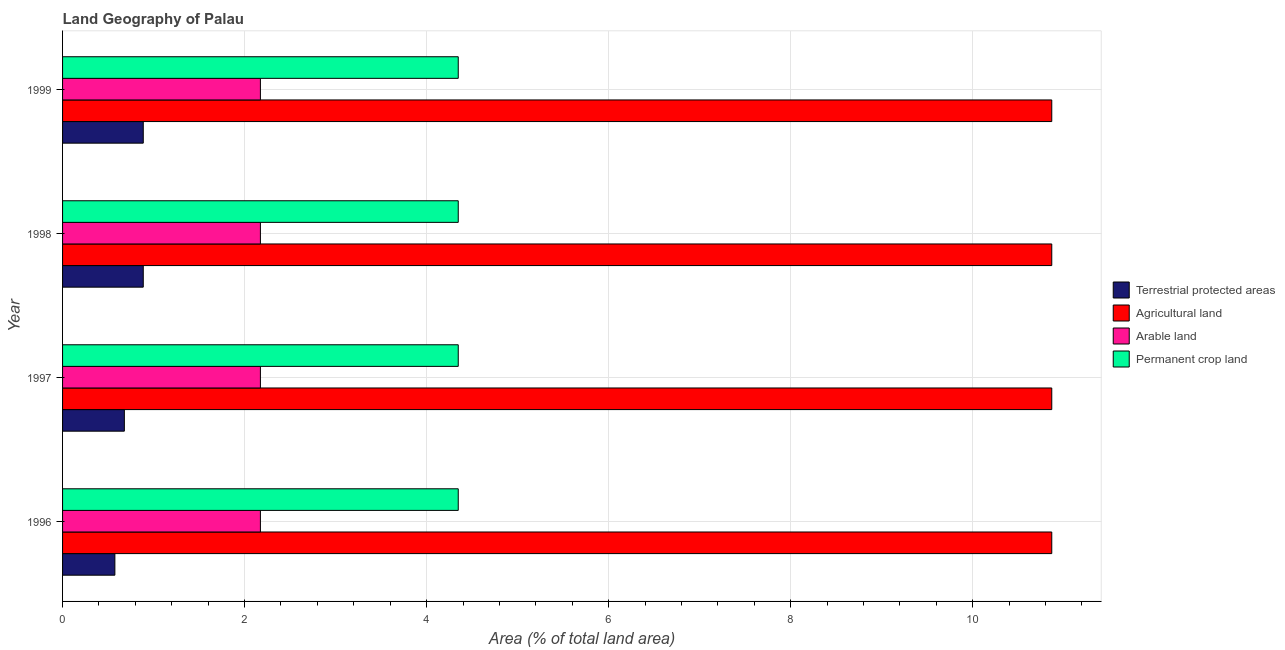What is the label of the 2nd group of bars from the top?
Provide a short and direct response. 1998. What is the percentage of area under permanent crop land in 1996?
Keep it short and to the point. 4.35. Across all years, what is the maximum percentage of area under arable land?
Provide a succinct answer. 2.17. Across all years, what is the minimum percentage of area under agricultural land?
Provide a succinct answer. 10.87. What is the total percentage of land under terrestrial protection in the graph?
Provide a short and direct response. 3.03. What is the difference between the percentage of land under terrestrial protection in 1996 and the percentage of area under permanent crop land in 1998?
Offer a very short reply. -3.77. What is the average percentage of land under terrestrial protection per year?
Make the answer very short. 0.76. In the year 1999, what is the difference between the percentage of area under arable land and percentage of area under agricultural land?
Your answer should be compact. -8.7. What is the ratio of the percentage of area under arable land in 1996 to that in 1997?
Provide a succinct answer. 1. What is the difference between the highest and the second highest percentage of area under arable land?
Offer a very short reply. 0. In how many years, is the percentage of land under terrestrial protection greater than the average percentage of land under terrestrial protection taken over all years?
Offer a terse response. 2. Is the sum of the percentage of area under permanent crop land in 1996 and 1999 greater than the maximum percentage of area under arable land across all years?
Provide a succinct answer. Yes. Is it the case that in every year, the sum of the percentage of area under arable land and percentage of land under terrestrial protection is greater than the sum of percentage of area under agricultural land and percentage of area under permanent crop land?
Your response must be concise. Yes. What does the 3rd bar from the top in 1997 represents?
Your response must be concise. Agricultural land. What does the 2nd bar from the bottom in 1998 represents?
Ensure brevity in your answer.  Agricultural land. Is it the case that in every year, the sum of the percentage of land under terrestrial protection and percentage of area under agricultural land is greater than the percentage of area under arable land?
Your answer should be compact. Yes. Are the values on the major ticks of X-axis written in scientific E-notation?
Provide a short and direct response. No. Does the graph contain any zero values?
Keep it short and to the point. No. How many legend labels are there?
Provide a succinct answer. 4. What is the title of the graph?
Your answer should be compact. Land Geography of Palau. Does "Oil" appear as one of the legend labels in the graph?
Give a very brief answer. No. What is the label or title of the X-axis?
Your response must be concise. Area (% of total land area). What is the Area (% of total land area) of Terrestrial protected areas in 1996?
Ensure brevity in your answer.  0.57. What is the Area (% of total land area) of Agricultural land in 1996?
Keep it short and to the point. 10.87. What is the Area (% of total land area) in Arable land in 1996?
Offer a very short reply. 2.17. What is the Area (% of total land area) in Permanent crop land in 1996?
Make the answer very short. 4.35. What is the Area (% of total land area) of Terrestrial protected areas in 1997?
Your answer should be compact. 0.68. What is the Area (% of total land area) in Agricultural land in 1997?
Ensure brevity in your answer.  10.87. What is the Area (% of total land area) in Arable land in 1997?
Give a very brief answer. 2.17. What is the Area (% of total land area) of Permanent crop land in 1997?
Provide a succinct answer. 4.35. What is the Area (% of total land area) of Terrestrial protected areas in 1998?
Your answer should be compact. 0.89. What is the Area (% of total land area) in Agricultural land in 1998?
Provide a succinct answer. 10.87. What is the Area (% of total land area) of Arable land in 1998?
Ensure brevity in your answer.  2.17. What is the Area (% of total land area) of Permanent crop land in 1998?
Give a very brief answer. 4.35. What is the Area (% of total land area) of Terrestrial protected areas in 1999?
Make the answer very short. 0.89. What is the Area (% of total land area) in Agricultural land in 1999?
Provide a succinct answer. 10.87. What is the Area (% of total land area) of Arable land in 1999?
Offer a terse response. 2.17. What is the Area (% of total land area) of Permanent crop land in 1999?
Your answer should be very brief. 4.35. Across all years, what is the maximum Area (% of total land area) in Terrestrial protected areas?
Offer a terse response. 0.89. Across all years, what is the maximum Area (% of total land area) of Agricultural land?
Your response must be concise. 10.87. Across all years, what is the maximum Area (% of total land area) in Arable land?
Give a very brief answer. 2.17. Across all years, what is the maximum Area (% of total land area) in Permanent crop land?
Provide a short and direct response. 4.35. Across all years, what is the minimum Area (% of total land area) in Terrestrial protected areas?
Offer a terse response. 0.57. Across all years, what is the minimum Area (% of total land area) in Agricultural land?
Make the answer very short. 10.87. Across all years, what is the minimum Area (% of total land area) of Arable land?
Give a very brief answer. 2.17. Across all years, what is the minimum Area (% of total land area) in Permanent crop land?
Give a very brief answer. 4.35. What is the total Area (% of total land area) in Terrestrial protected areas in the graph?
Keep it short and to the point. 3.03. What is the total Area (% of total land area) of Agricultural land in the graph?
Offer a very short reply. 43.48. What is the total Area (% of total land area) in Arable land in the graph?
Your answer should be very brief. 8.7. What is the total Area (% of total land area) in Permanent crop land in the graph?
Your answer should be compact. 17.39. What is the difference between the Area (% of total land area) in Terrestrial protected areas in 1996 and that in 1997?
Provide a succinct answer. -0.1. What is the difference between the Area (% of total land area) of Agricultural land in 1996 and that in 1997?
Make the answer very short. 0. What is the difference between the Area (% of total land area) in Arable land in 1996 and that in 1997?
Your answer should be very brief. 0. What is the difference between the Area (% of total land area) of Terrestrial protected areas in 1996 and that in 1998?
Provide a short and direct response. -0.31. What is the difference between the Area (% of total land area) in Agricultural land in 1996 and that in 1998?
Provide a short and direct response. 0. What is the difference between the Area (% of total land area) of Terrestrial protected areas in 1996 and that in 1999?
Ensure brevity in your answer.  -0.31. What is the difference between the Area (% of total land area) in Agricultural land in 1996 and that in 1999?
Provide a short and direct response. 0. What is the difference between the Area (% of total land area) in Permanent crop land in 1996 and that in 1999?
Your answer should be very brief. 0. What is the difference between the Area (% of total land area) in Terrestrial protected areas in 1997 and that in 1998?
Offer a very short reply. -0.21. What is the difference between the Area (% of total land area) of Agricultural land in 1997 and that in 1998?
Ensure brevity in your answer.  0. What is the difference between the Area (% of total land area) of Terrestrial protected areas in 1997 and that in 1999?
Provide a short and direct response. -0.21. What is the difference between the Area (% of total land area) in Agricultural land in 1997 and that in 1999?
Ensure brevity in your answer.  0. What is the difference between the Area (% of total land area) in Arable land in 1997 and that in 1999?
Offer a very short reply. 0. What is the difference between the Area (% of total land area) of Permanent crop land in 1997 and that in 1999?
Offer a very short reply. 0. What is the difference between the Area (% of total land area) in Terrestrial protected areas in 1998 and that in 1999?
Keep it short and to the point. 0. What is the difference between the Area (% of total land area) of Agricultural land in 1998 and that in 1999?
Your answer should be very brief. 0. What is the difference between the Area (% of total land area) in Arable land in 1998 and that in 1999?
Ensure brevity in your answer.  0. What is the difference between the Area (% of total land area) of Permanent crop land in 1998 and that in 1999?
Ensure brevity in your answer.  0. What is the difference between the Area (% of total land area) of Terrestrial protected areas in 1996 and the Area (% of total land area) of Agricultural land in 1997?
Ensure brevity in your answer.  -10.29. What is the difference between the Area (% of total land area) of Terrestrial protected areas in 1996 and the Area (% of total land area) of Arable land in 1997?
Your answer should be very brief. -1.6. What is the difference between the Area (% of total land area) in Terrestrial protected areas in 1996 and the Area (% of total land area) in Permanent crop land in 1997?
Ensure brevity in your answer.  -3.77. What is the difference between the Area (% of total land area) of Agricultural land in 1996 and the Area (% of total land area) of Arable land in 1997?
Make the answer very short. 8.7. What is the difference between the Area (% of total land area) in Agricultural land in 1996 and the Area (% of total land area) in Permanent crop land in 1997?
Your answer should be very brief. 6.52. What is the difference between the Area (% of total land area) of Arable land in 1996 and the Area (% of total land area) of Permanent crop land in 1997?
Give a very brief answer. -2.17. What is the difference between the Area (% of total land area) in Terrestrial protected areas in 1996 and the Area (% of total land area) in Agricultural land in 1998?
Your answer should be very brief. -10.29. What is the difference between the Area (% of total land area) in Terrestrial protected areas in 1996 and the Area (% of total land area) in Arable land in 1998?
Offer a terse response. -1.6. What is the difference between the Area (% of total land area) in Terrestrial protected areas in 1996 and the Area (% of total land area) in Permanent crop land in 1998?
Offer a very short reply. -3.77. What is the difference between the Area (% of total land area) of Agricultural land in 1996 and the Area (% of total land area) of Arable land in 1998?
Give a very brief answer. 8.7. What is the difference between the Area (% of total land area) of Agricultural land in 1996 and the Area (% of total land area) of Permanent crop land in 1998?
Make the answer very short. 6.52. What is the difference between the Area (% of total land area) of Arable land in 1996 and the Area (% of total land area) of Permanent crop land in 1998?
Provide a succinct answer. -2.17. What is the difference between the Area (% of total land area) in Terrestrial protected areas in 1996 and the Area (% of total land area) in Agricultural land in 1999?
Provide a succinct answer. -10.29. What is the difference between the Area (% of total land area) in Terrestrial protected areas in 1996 and the Area (% of total land area) in Arable land in 1999?
Keep it short and to the point. -1.6. What is the difference between the Area (% of total land area) in Terrestrial protected areas in 1996 and the Area (% of total land area) in Permanent crop land in 1999?
Offer a terse response. -3.77. What is the difference between the Area (% of total land area) of Agricultural land in 1996 and the Area (% of total land area) of Arable land in 1999?
Keep it short and to the point. 8.7. What is the difference between the Area (% of total land area) of Agricultural land in 1996 and the Area (% of total land area) of Permanent crop land in 1999?
Your answer should be compact. 6.52. What is the difference between the Area (% of total land area) in Arable land in 1996 and the Area (% of total land area) in Permanent crop land in 1999?
Your response must be concise. -2.17. What is the difference between the Area (% of total land area) of Terrestrial protected areas in 1997 and the Area (% of total land area) of Agricultural land in 1998?
Give a very brief answer. -10.19. What is the difference between the Area (% of total land area) in Terrestrial protected areas in 1997 and the Area (% of total land area) in Arable land in 1998?
Your answer should be compact. -1.5. What is the difference between the Area (% of total land area) in Terrestrial protected areas in 1997 and the Area (% of total land area) in Permanent crop land in 1998?
Offer a very short reply. -3.67. What is the difference between the Area (% of total land area) in Agricultural land in 1997 and the Area (% of total land area) in Arable land in 1998?
Offer a very short reply. 8.7. What is the difference between the Area (% of total land area) of Agricultural land in 1997 and the Area (% of total land area) of Permanent crop land in 1998?
Offer a terse response. 6.52. What is the difference between the Area (% of total land area) in Arable land in 1997 and the Area (% of total land area) in Permanent crop land in 1998?
Provide a short and direct response. -2.17. What is the difference between the Area (% of total land area) in Terrestrial protected areas in 1997 and the Area (% of total land area) in Agricultural land in 1999?
Give a very brief answer. -10.19. What is the difference between the Area (% of total land area) in Terrestrial protected areas in 1997 and the Area (% of total land area) in Arable land in 1999?
Your answer should be very brief. -1.5. What is the difference between the Area (% of total land area) of Terrestrial protected areas in 1997 and the Area (% of total land area) of Permanent crop land in 1999?
Your response must be concise. -3.67. What is the difference between the Area (% of total land area) of Agricultural land in 1997 and the Area (% of total land area) of Arable land in 1999?
Give a very brief answer. 8.7. What is the difference between the Area (% of total land area) of Agricultural land in 1997 and the Area (% of total land area) of Permanent crop land in 1999?
Provide a short and direct response. 6.52. What is the difference between the Area (% of total land area) in Arable land in 1997 and the Area (% of total land area) in Permanent crop land in 1999?
Give a very brief answer. -2.17. What is the difference between the Area (% of total land area) in Terrestrial protected areas in 1998 and the Area (% of total land area) in Agricultural land in 1999?
Provide a short and direct response. -9.98. What is the difference between the Area (% of total land area) of Terrestrial protected areas in 1998 and the Area (% of total land area) of Arable land in 1999?
Make the answer very short. -1.29. What is the difference between the Area (% of total land area) of Terrestrial protected areas in 1998 and the Area (% of total land area) of Permanent crop land in 1999?
Keep it short and to the point. -3.46. What is the difference between the Area (% of total land area) in Agricultural land in 1998 and the Area (% of total land area) in Arable land in 1999?
Give a very brief answer. 8.7. What is the difference between the Area (% of total land area) in Agricultural land in 1998 and the Area (% of total land area) in Permanent crop land in 1999?
Your answer should be compact. 6.52. What is the difference between the Area (% of total land area) in Arable land in 1998 and the Area (% of total land area) in Permanent crop land in 1999?
Provide a short and direct response. -2.17. What is the average Area (% of total land area) of Terrestrial protected areas per year?
Keep it short and to the point. 0.76. What is the average Area (% of total land area) in Agricultural land per year?
Your response must be concise. 10.87. What is the average Area (% of total land area) in Arable land per year?
Offer a terse response. 2.17. What is the average Area (% of total land area) in Permanent crop land per year?
Your answer should be compact. 4.35. In the year 1996, what is the difference between the Area (% of total land area) of Terrestrial protected areas and Area (% of total land area) of Agricultural land?
Your answer should be very brief. -10.29. In the year 1996, what is the difference between the Area (% of total land area) of Terrestrial protected areas and Area (% of total land area) of Arable land?
Ensure brevity in your answer.  -1.6. In the year 1996, what is the difference between the Area (% of total land area) of Terrestrial protected areas and Area (% of total land area) of Permanent crop land?
Offer a terse response. -3.77. In the year 1996, what is the difference between the Area (% of total land area) in Agricultural land and Area (% of total land area) in Arable land?
Make the answer very short. 8.7. In the year 1996, what is the difference between the Area (% of total land area) in Agricultural land and Area (% of total land area) in Permanent crop land?
Provide a short and direct response. 6.52. In the year 1996, what is the difference between the Area (% of total land area) in Arable land and Area (% of total land area) in Permanent crop land?
Offer a terse response. -2.17. In the year 1997, what is the difference between the Area (% of total land area) of Terrestrial protected areas and Area (% of total land area) of Agricultural land?
Make the answer very short. -10.19. In the year 1997, what is the difference between the Area (% of total land area) in Terrestrial protected areas and Area (% of total land area) in Arable land?
Provide a short and direct response. -1.5. In the year 1997, what is the difference between the Area (% of total land area) of Terrestrial protected areas and Area (% of total land area) of Permanent crop land?
Keep it short and to the point. -3.67. In the year 1997, what is the difference between the Area (% of total land area) of Agricultural land and Area (% of total land area) of Arable land?
Your response must be concise. 8.7. In the year 1997, what is the difference between the Area (% of total land area) of Agricultural land and Area (% of total land area) of Permanent crop land?
Ensure brevity in your answer.  6.52. In the year 1997, what is the difference between the Area (% of total land area) in Arable land and Area (% of total land area) in Permanent crop land?
Provide a short and direct response. -2.17. In the year 1998, what is the difference between the Area (% of total land area) in Terrestrial protected areas and Area (% of total land area) in Agricultural land?
Offer a terse response. -9.98. In the year 1998, what is the difference between the Area (% of total land area) in Terrestrial protected areas and Area (% of total land area) in Arable land?
Keep it short and to the point. -1.29. In the year 1998, what is the difference between the Area (% of total land area) of Terrestrial protected areas and Area (% of total land area) of Permanent crop land?
Provide a succinct answer. -3.46. In the year 1998, what is the difference between the Area (% of total land area) in Agricultural land and Area (% of total land area) in Arable land?
Your response must be concise. 8.7. In the year 1998, what is the difference between the Area (% of total land area) in Agricultural land and Area (% of total land area) in Permanent crop land?
Offer a very short reply. 6.52. In the year 1998, what is the difference between the Area (% of total land area) in Arable land and Area (% of total land area) in Permanent crop land?
Make the answer very short. -2.17. In the year 1999, what is the difference between the Area (% of total land area) in Terrestrial protected areas and Area (% of total land area) in Agricultural land?
Your answer should be compact. -9.98. In the year 1999, what is the difference between the Area (% of total land area) in Terrestrial protected areas and Area (% of total land area) in Arable land?
Ensure brevity in your answer.  -1.29. In the year 1999, what is the difference between the Area (% of total land area) in Terrestrial protected areas and Area (% of total land area) in Permanent crop land?
Offer a terse response. -3.46. In the year 1999, what is the difference between the Area (% of total land area) of Agricultural land and Area (% of total land area) of Arable land?
Ensure brevity in your answer.  8.7. In the year 1999, what is the difference between the Area (% of total land area) in Agricultural land and Area (% of total land area) in Permanent crop land?
Offer a very short reply. 6.52. In the year 1999, what is the difference between the Area (% of total land area) in Arable land and Area (% of total land area) in Permanent crop land?
Keep it short and to the point. -2.17. What is the ratio of the Area (% of total land area) in Terrestrial protected areas in 1996 to that in 1997?
Make the answer very short. 0.85. What is the ratio of the Area (% of total land area) in Agricultural land in 1996 to that in 1997?
Ensure brevity in your answer.  1. What is the ratio of the Area (% of total land area) of Terrestrial protected areas in 1996 to that in 1998?
Your answer should be very brief. 0.65. What is the ratio of the Area (% of total land area) in Agricultural land in 1996 to that in 1998?
Keep it short and to the point. 1. What is the ratio of the Area (% of total land area) of Terrestrial protected areas in 1996 to that in 1999?
Your response must be concise. 0.65. What is the ratio of the Area (% of total land area) of Arable land in 1996 to that in 1999?
Your response must be concise. 1. What is the ratio of the Area (% of total land area) in Permanent crop land in 1996 to that in 1999?
Ensure brevity in your answer.  1. What is the ratio of the Area (% of total land area) of Terrestrial protected areas in 1997 to that in 1998?
Make the answer very short. 0.77. What is the ratio of the Area (% of total land area) of Terrestrial protected areas in 1997 to that in 1999?
Make the answer very short. 0.77. What is the ratio of the Area (% of total land area) of Arable land in 1997 to that in 1999?
Give a very brief answer. 1. What is the ratio of the Area (% of total land area) of Permanent crop land in 1997 to that in 1999?
Provide a short and direct response. 1. What is the ratio of the Area (% of total land area) of Terrestrial protected areas in 1998 to that in 1999?
Keep it short and to the point. 1. What is the ratio of the Area (% of total land area) in Arable land in 1998 to that in 1999?
Provide a succinct answer. 1. What is the ratio of the Area (% of total land area) in Permanent crop land in 1998 to that in 1999?
Provide a succinct answer. 1. What is the difference between the highest and the lowest Area (% of total land area) in Terrestrial protected areas?
Provide a short and direct response. 0.31. What is the difference between the highest and the lowest Area (% of total land area) in Agricultural land?
Your answer should be compact. 0. 